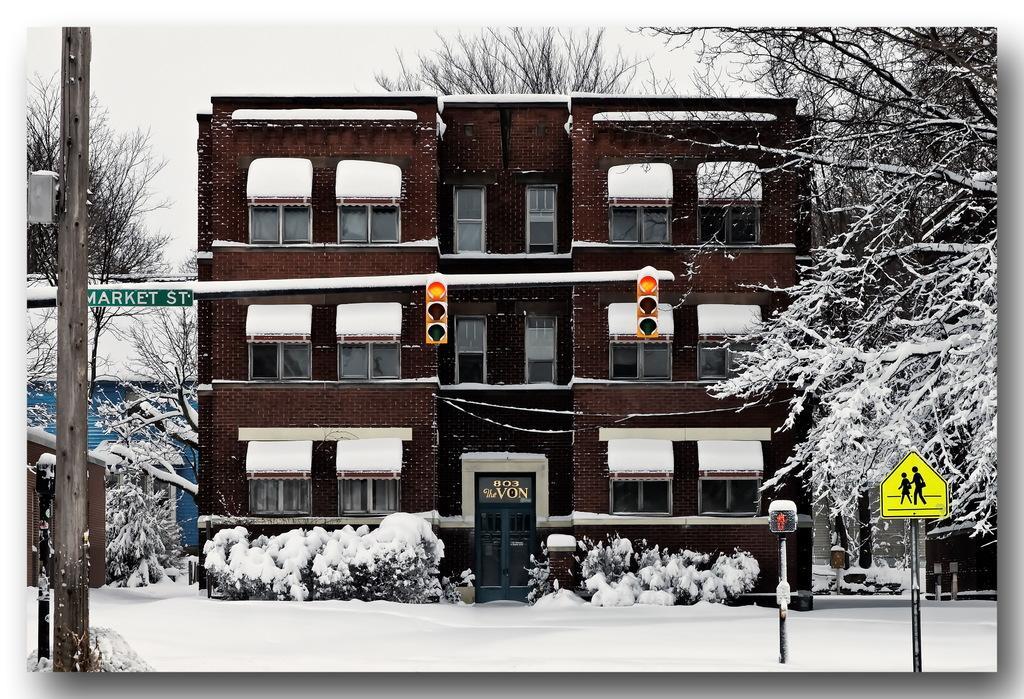How would you summarize this image in a sentence or two? In this picture there is a building. In front of the door we can see plants. Here we can see your traffic signals and sign boards. On the bottom we can see snow. In the background we can see a shed and many trees. At the top we can see sky and clouds. 